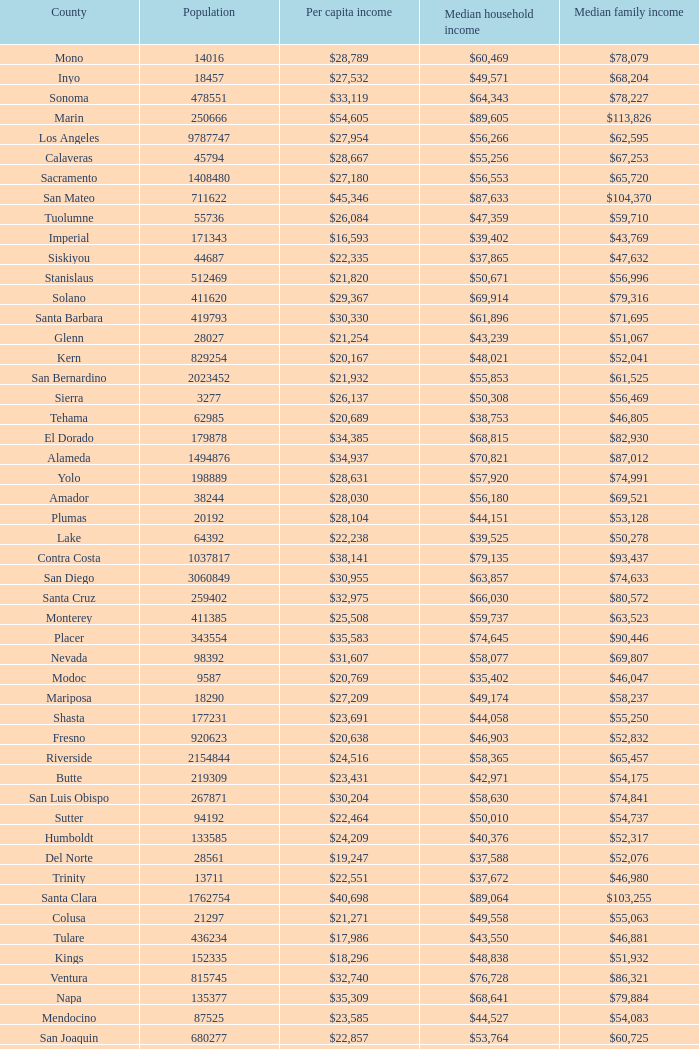What is the per capita income of shasta? $23,691. 